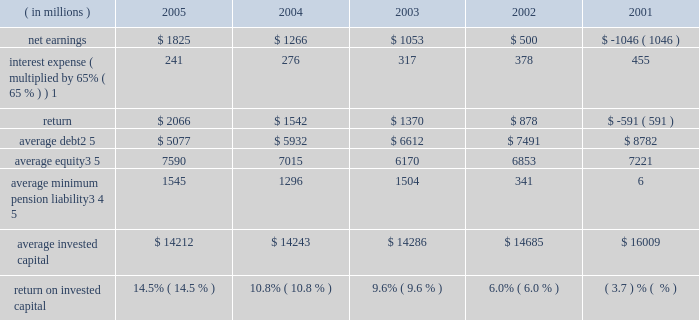Page 74 notes to five year summary ( a ) includes the effects of items not considered in senior management 2019s assessment of the operating performance of the corporation 2019s business segments ( see the section , 201cresults of operations 201d in management 2019s discussion and analysis of financial condition and results of operations ( md&a ) ) which , on a combined basis , increased earnings from continuing operations before income taxes by $ 173 million , $ 113 million after tax ( $ 0.25 per share ) .
( b ) includes the effects of items not considered in senior management 2019s assessment of the operating performance of the corporation 2019s business segments ( see the section , 201cresults of operations 201d in md&a ) which , on a combined basis , decreased earnings from continuing operations before income taxes by $ 215 million , $ 154 million after tax ( $ 0.34 per share ) .
Also includes a reduction in income tax expense resulting from the closure of an internal revenue service examination of $ 144 million ( $ 0.32 per share ) .
These items reduced earnings by $ 10 million after tax ( $ 0.02 per share ) .
( c ) includes the effects of items not considered in senior management 2019s assessment of the operating performance of the corporation 2019s business segments ( see the section , 201cresults of operations 201d in md&a ) which , on a combined basis , decreased earnings from continuing operations before income taxes by $ 153 million , $ 102 million after tax ( $ 0.22 per share ) .
( d ) includes the effects of items not considered in senior management 2019s assessment of the operating performance of the corporation 2019s business segments which , on a combined basis , decreased earnings from continuing operations before income taxes by $ 1112 million , $ 632 million after tax ( $ 1.40 per share ) .
In 2002 , the corporation adopted fas 142 which prohibits the amortization of goodwill .
( e ) includes the effects of items not considered in senior management 2019s assessment of the operating performance of the corporation 2019s business segments which , on a combined basis , decreased earnings from continuing operations before income taxes by $ 973 million , $ 651 million after tax ( $ 1.50 per share ) .
Also includes a gain from the disposal of a business and charges for the corporation 2019s exit from its global telecommunications services business which is included in discontinued operations and which , on a combined basis , increased the net loss by $ 1 billion ( $ 2.38 per share ) .
( f ) the corporation defines return on invested capital ( roic ) as net income plus after-tax interest expense divided by average invested capital ( stockholders 2019 equity plus debt ) , after adjusting stockholders 2019 equity by adding back the minimum pension liability .
The adjustment to add back the minimum pension liability is a revision to our calculation in 2005 , which the corporation believes more closely links roic to management performance .
Further , the corporation believes that reporting roic provides investors with greater visibility into how effectively lockheed martin uses the capital invested in its operations .
The corporation uses roic to evaluate multi-year investment decisions and as a long-term performance measure , and also uses roic as a factor in evaluating management performance under certain incentive compensation plans .
Roic is not a measure of financial performance under gaap , and may not be defined and calculated by other companies in the same manner .
Roic should not be considered in isola- tion or as an alternative to net earnings as an indicator of performance .
The following calculations of roic reflect the revision to the calculation discussed above for all periods presented .
( in millions ) 2005 2004 2003 2002 2001 .
1 represents after-tax interest expense utilizing the federal statutory rate of 35% ( 35 % ) .
2 debt consists of long-term debt , including current maturities , and short-term borrowings ( if any ) .
3 equity includes non-cash adjustments for other comprehensive losses , primarily for the additional minimum pension liability .
4 minimum pension liability values reflect the cumulative value of entries identified in our statement of stockholders equity under the caption 201cminimum pension liability . 201d the annual minimum pension liability adjustments to equity were : 2001 = ( $ 33 million ) ; 2002 = ( $ 1537 million ) ; 2003 = $ 331 million ; 2004 = ( $ 285 million ) ; 2005 = ( $ 105 million ) .
As these entries are recorded in the fourth quarter , the value added back to our average equity in a given year is the cumulative impact of all prior year entries plus 20% ( 20 % ) of the cur- rent year entry value .
5 yearly averages are calculated using balances at the start of the year and at the end of each quarter .
Lockheed martin corporation .
What was the average net earnings in millions from 2001 to 2005? 
Computations: table_average(net earnings, none)
Answer: 719.6. 